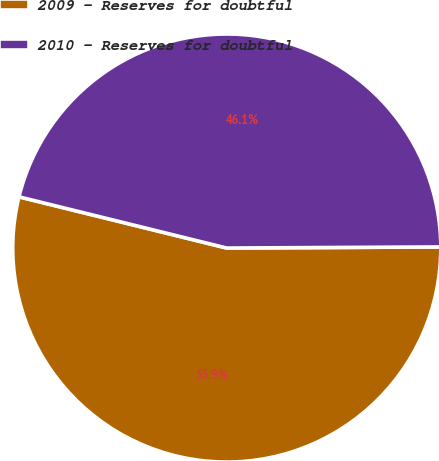<chart> <loc_0><loc_0><loc_500><loc_500><pie_chart><fcel>2009 - Reserves for doubtful<fcel>2010 - Reserves for doubtful<nl><fcel>53.93%<fcel>46.07%<nl></chart> 